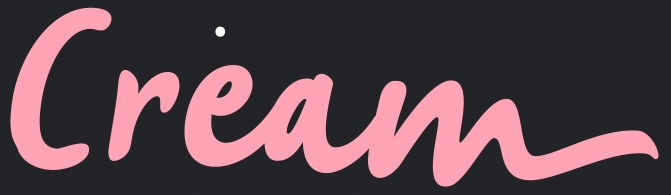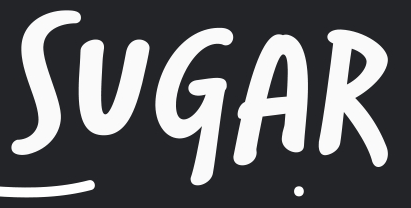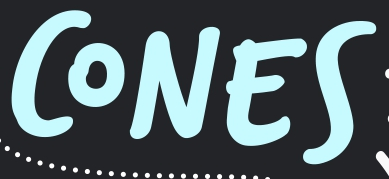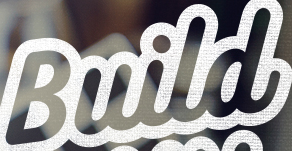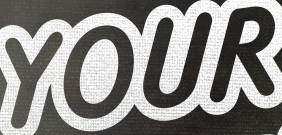What text is displayed in these images sequentially, separated by a semicolon? Cream; SUGAR; CONES; Build; YOUR 